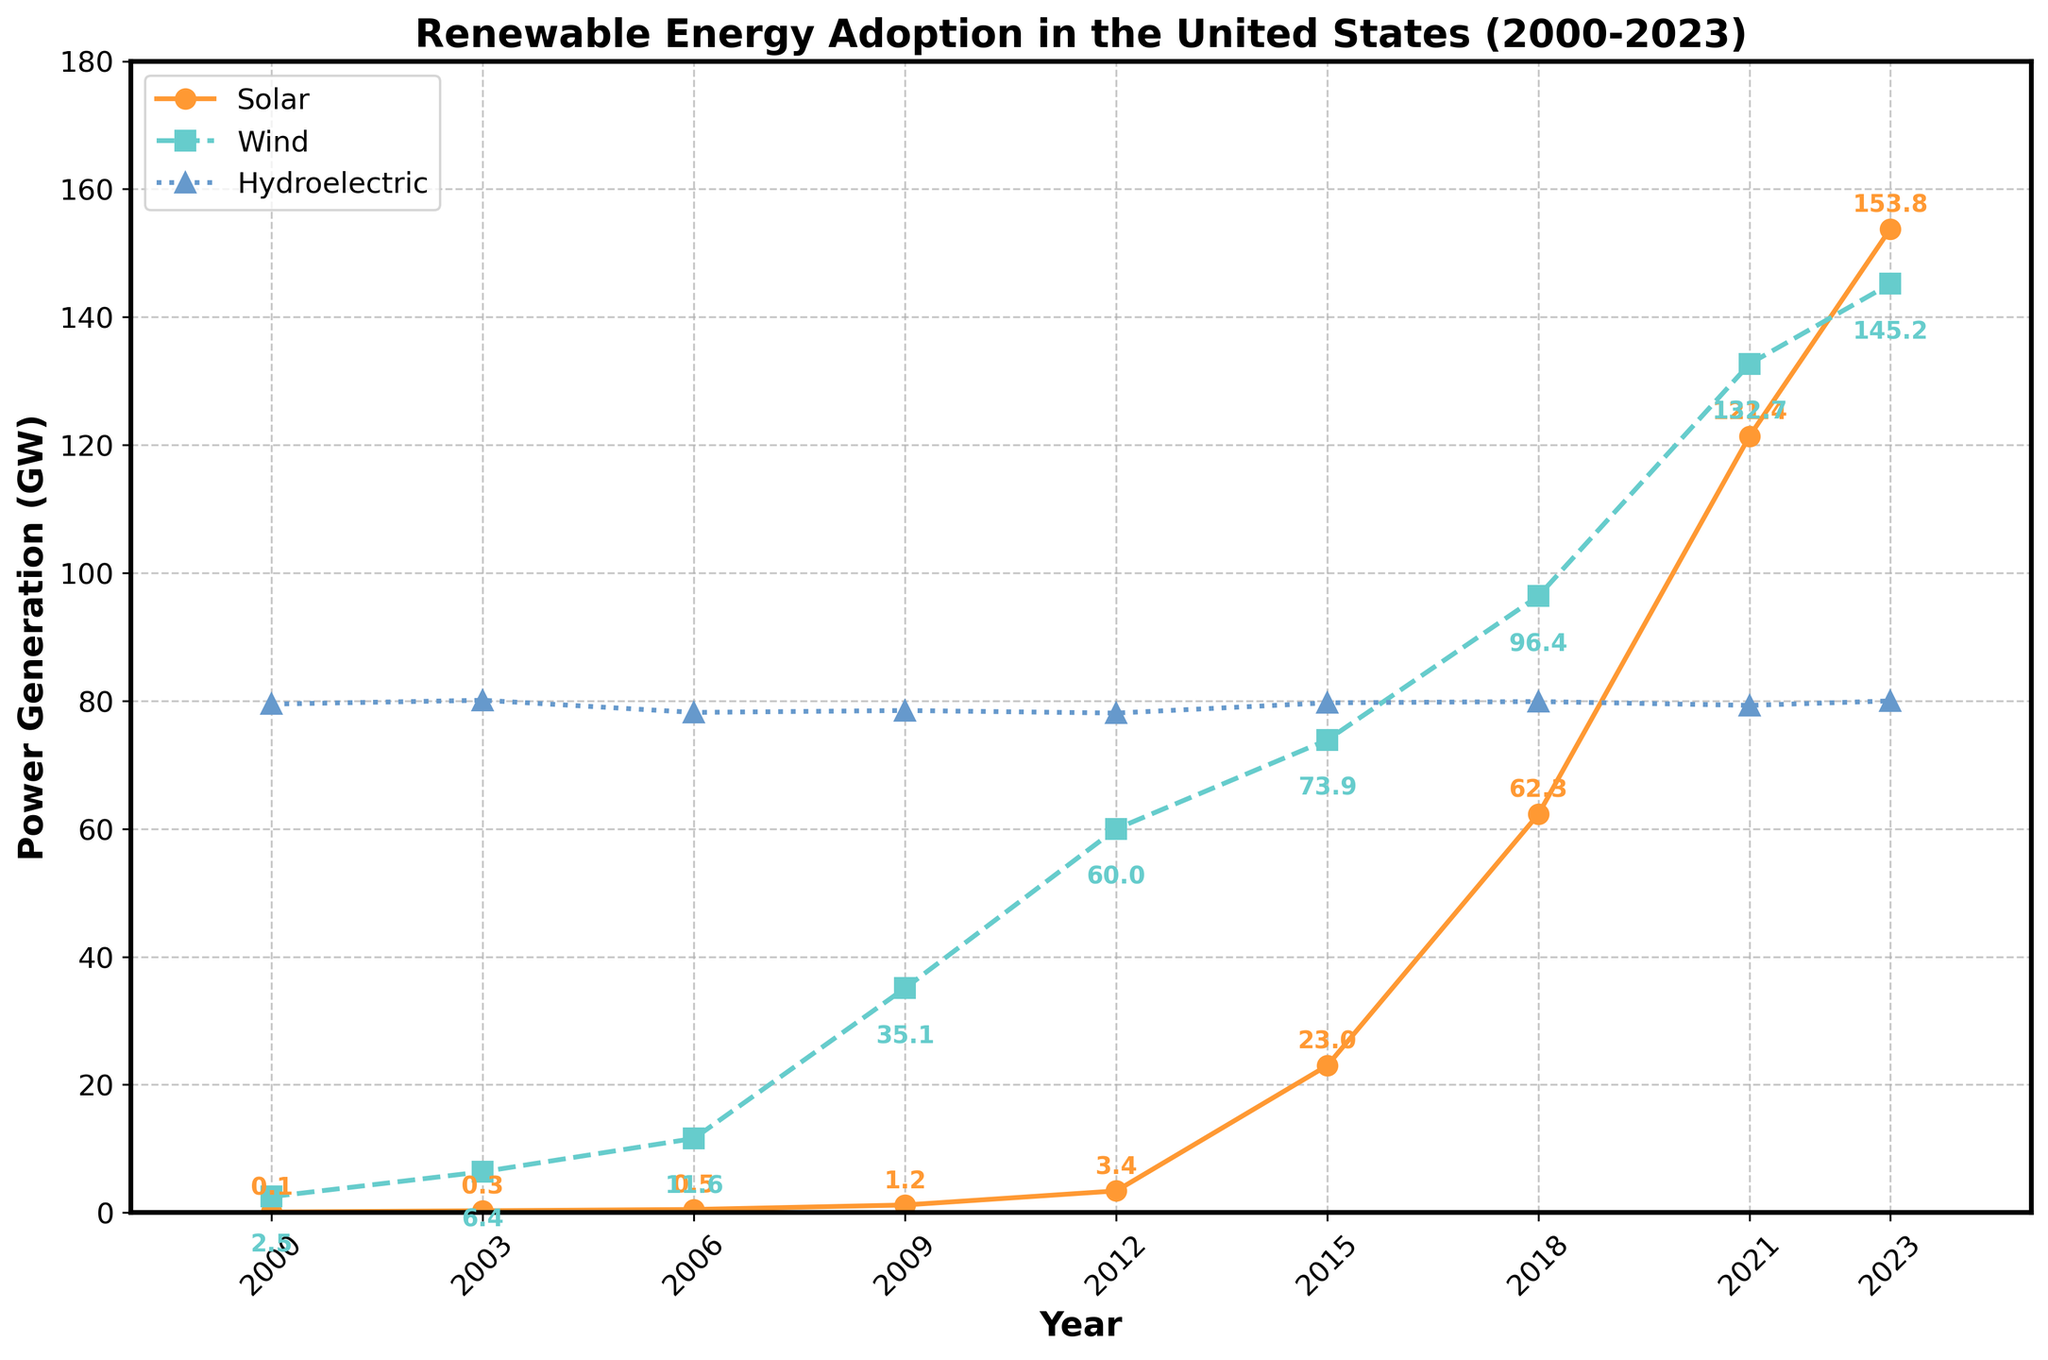What's the overall trend for solar power generation from 2000 to 2023? The line for solar power generation increases steadily over the years from 0.1 GW in 2000 to 153.8 GW in 2023.
Answer: Increasing Which renewable energy source had the most significant growth in terms of GW between 2000 and 2023? Solar power increased from 0.1 GW to 153.8 GW, wind from 2.5 GW to 145.2 GW, and hydroelectric slightly fluctuated around 79.5 GW. Solar had the most significant growth.
Answer: Solar How does wind power generation in 2023 compare to solar power generation in 2015? Wind power in 2023 is 145.2 GW, and solar power in 2015 was 23.0 GW. Wind power generation in 2023 is significantly higher.
Answer: Wind power in 2023 is higher What is the approximate difference in GW between solar and wind power generation in 2023? Solar power is 153.8 GW, and wind power is 145.2 GW. The difference is 153.8 - 145.2 = 8.6 GW.
Answer: 8.6 GW Which year saw the most significant increase in wind power generation compared to the preceding recorded year? From 2006 to 2009, wind power increased from 11.6 GW to 35.1 GW, a difference of 23.5 GW, which is the most significant single increase.
Answer: 2006 to 2009 By how much did solar power generation increase between 2018 and 2021? Solar power generation increased from 62.3 GW in 2018 to 121.4 GW in 2021. The difference is 121.4 - 62.3 = 59.1 GW.
Answer: 59.1 GW How stable has hydroelectric power generation been over the years? Hydroelectric power generation fluctuated slightly around 79.5 GW, with small changes each year, indicating stability.
Answer: Stable Between which consecutive given years did solar power witness the highest relative growth percentage-wise? Relative growth can be computed by (New Value - Old Value) / Old Value * 100%. From 2012 to 2015, solar power increased from 3.4 GW to 23.0 GW. The growth is ((23.0 - 3.4) / 3.4) * 100% ≈ 576.47%, the highest relative growth.
Answer: 2012 to 2015 Which renewable energy source consistently showed the highest power generation throughout the entire timeline? Hydroelectric power consistently generated around 79.5 GW, the highest among the three sources over the entire timeline.
Answer: Hydroelectric What was the approximate combined power generation of solar, wind, and hydroelectric energy in 2023? Adding the values in 2023: 153.8 GW (solar) + 145.2 GW (wind) + 80.0 GW (hydroelectric) = 379.0 GW.
Answer: 379.0 GW 